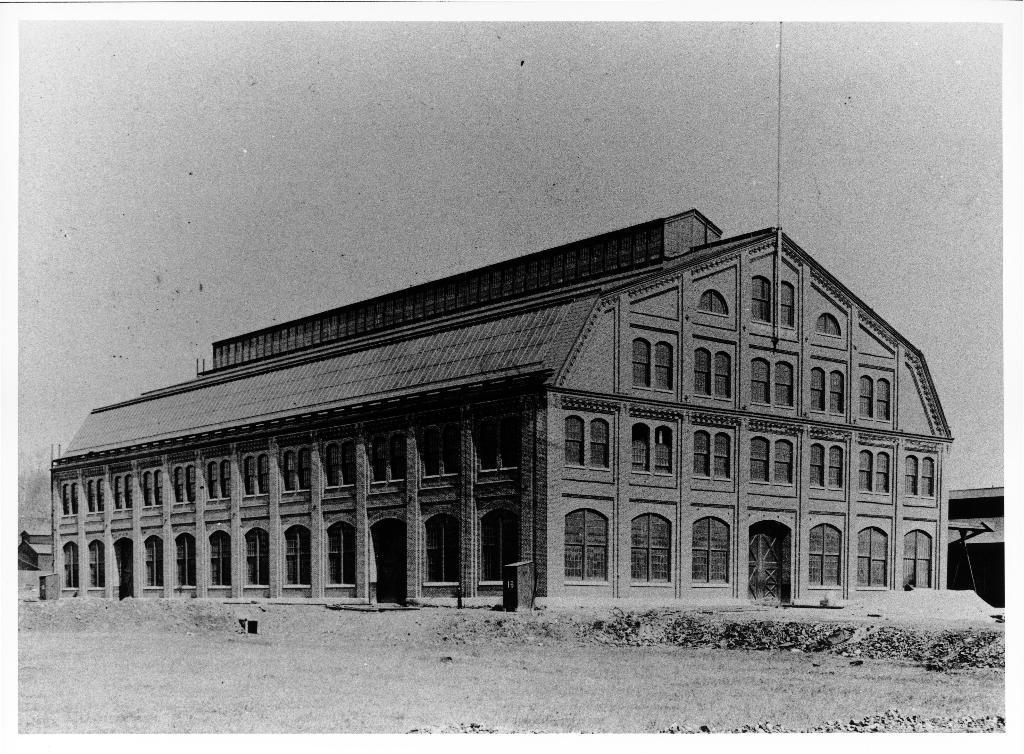In one or two sentences, can you explain what this image depicts? This is a black and white image. In this image we can see a building with roof, doors and some windows. We can also see the sky. 